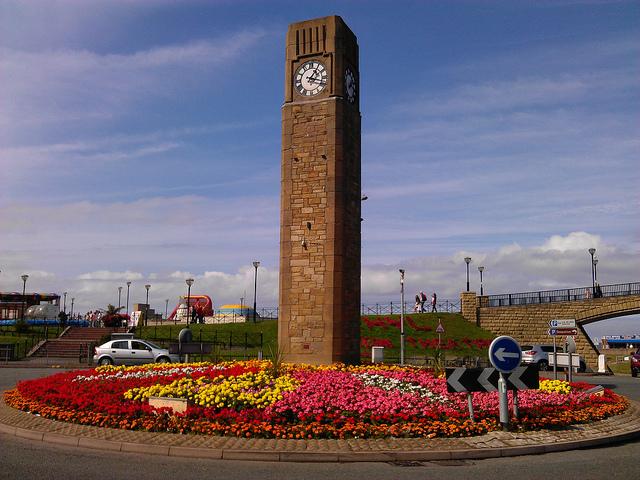What tower is this?
Keep it brief. Clock. What is the brick structure to the far right of the photo?
Quick response, please. Bridge. What is the name of the tower?
Keep it brief. Clock. What time does the clock say?
Be succinct. 1:20. How tall is the monument?
Keep it brief. 20 feet. What monument is in the background?
Give a very brief answer. Clock tower. How tall is the clock tower?
Answer briefly. Tall. 